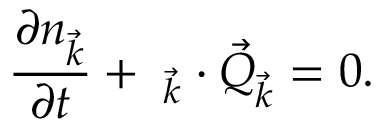<formula> <loc_0><loc_0><loc_500><loc_500>\frac { \partial n _ { \vec { k } } } { \partial t } + \mathbf \nabla _ { \vec { k } } \cdot \vec { Q } _ { \vec { k } } = 0 .</formula> 